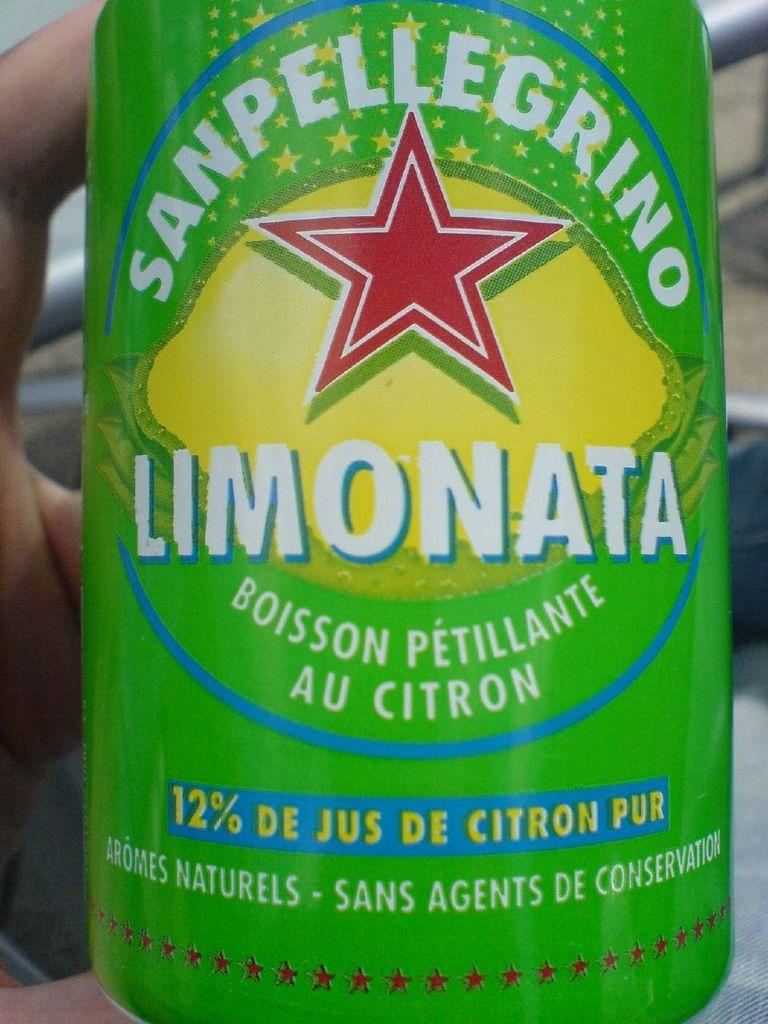Provide a one-sentence caption for the provided image. A hand holds a can of Limonata by Sanpelligrino. 